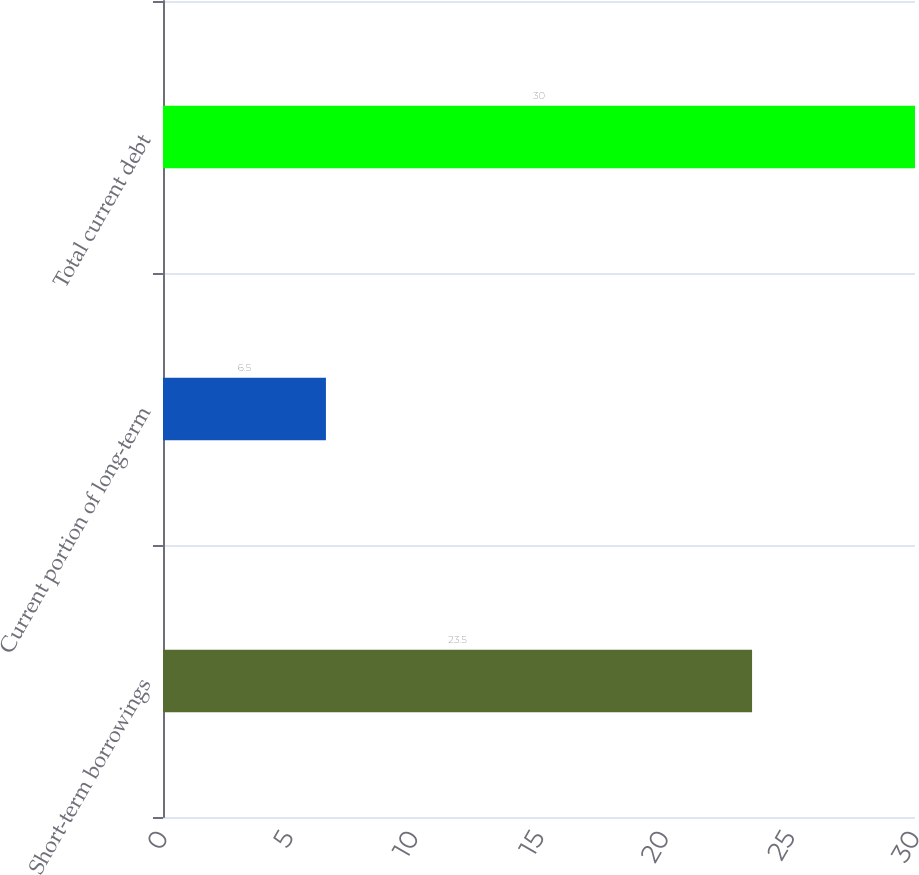Convert chart. <chart><loc_0><loc_0><loc_500><loc_500><bar_chart><fcel>Short-term borrowings<fcel>Current portion of long-term<fcel>Total current debt<nl><fcel>23.5<fcel>6.5<fcel>30<nl></chart> 